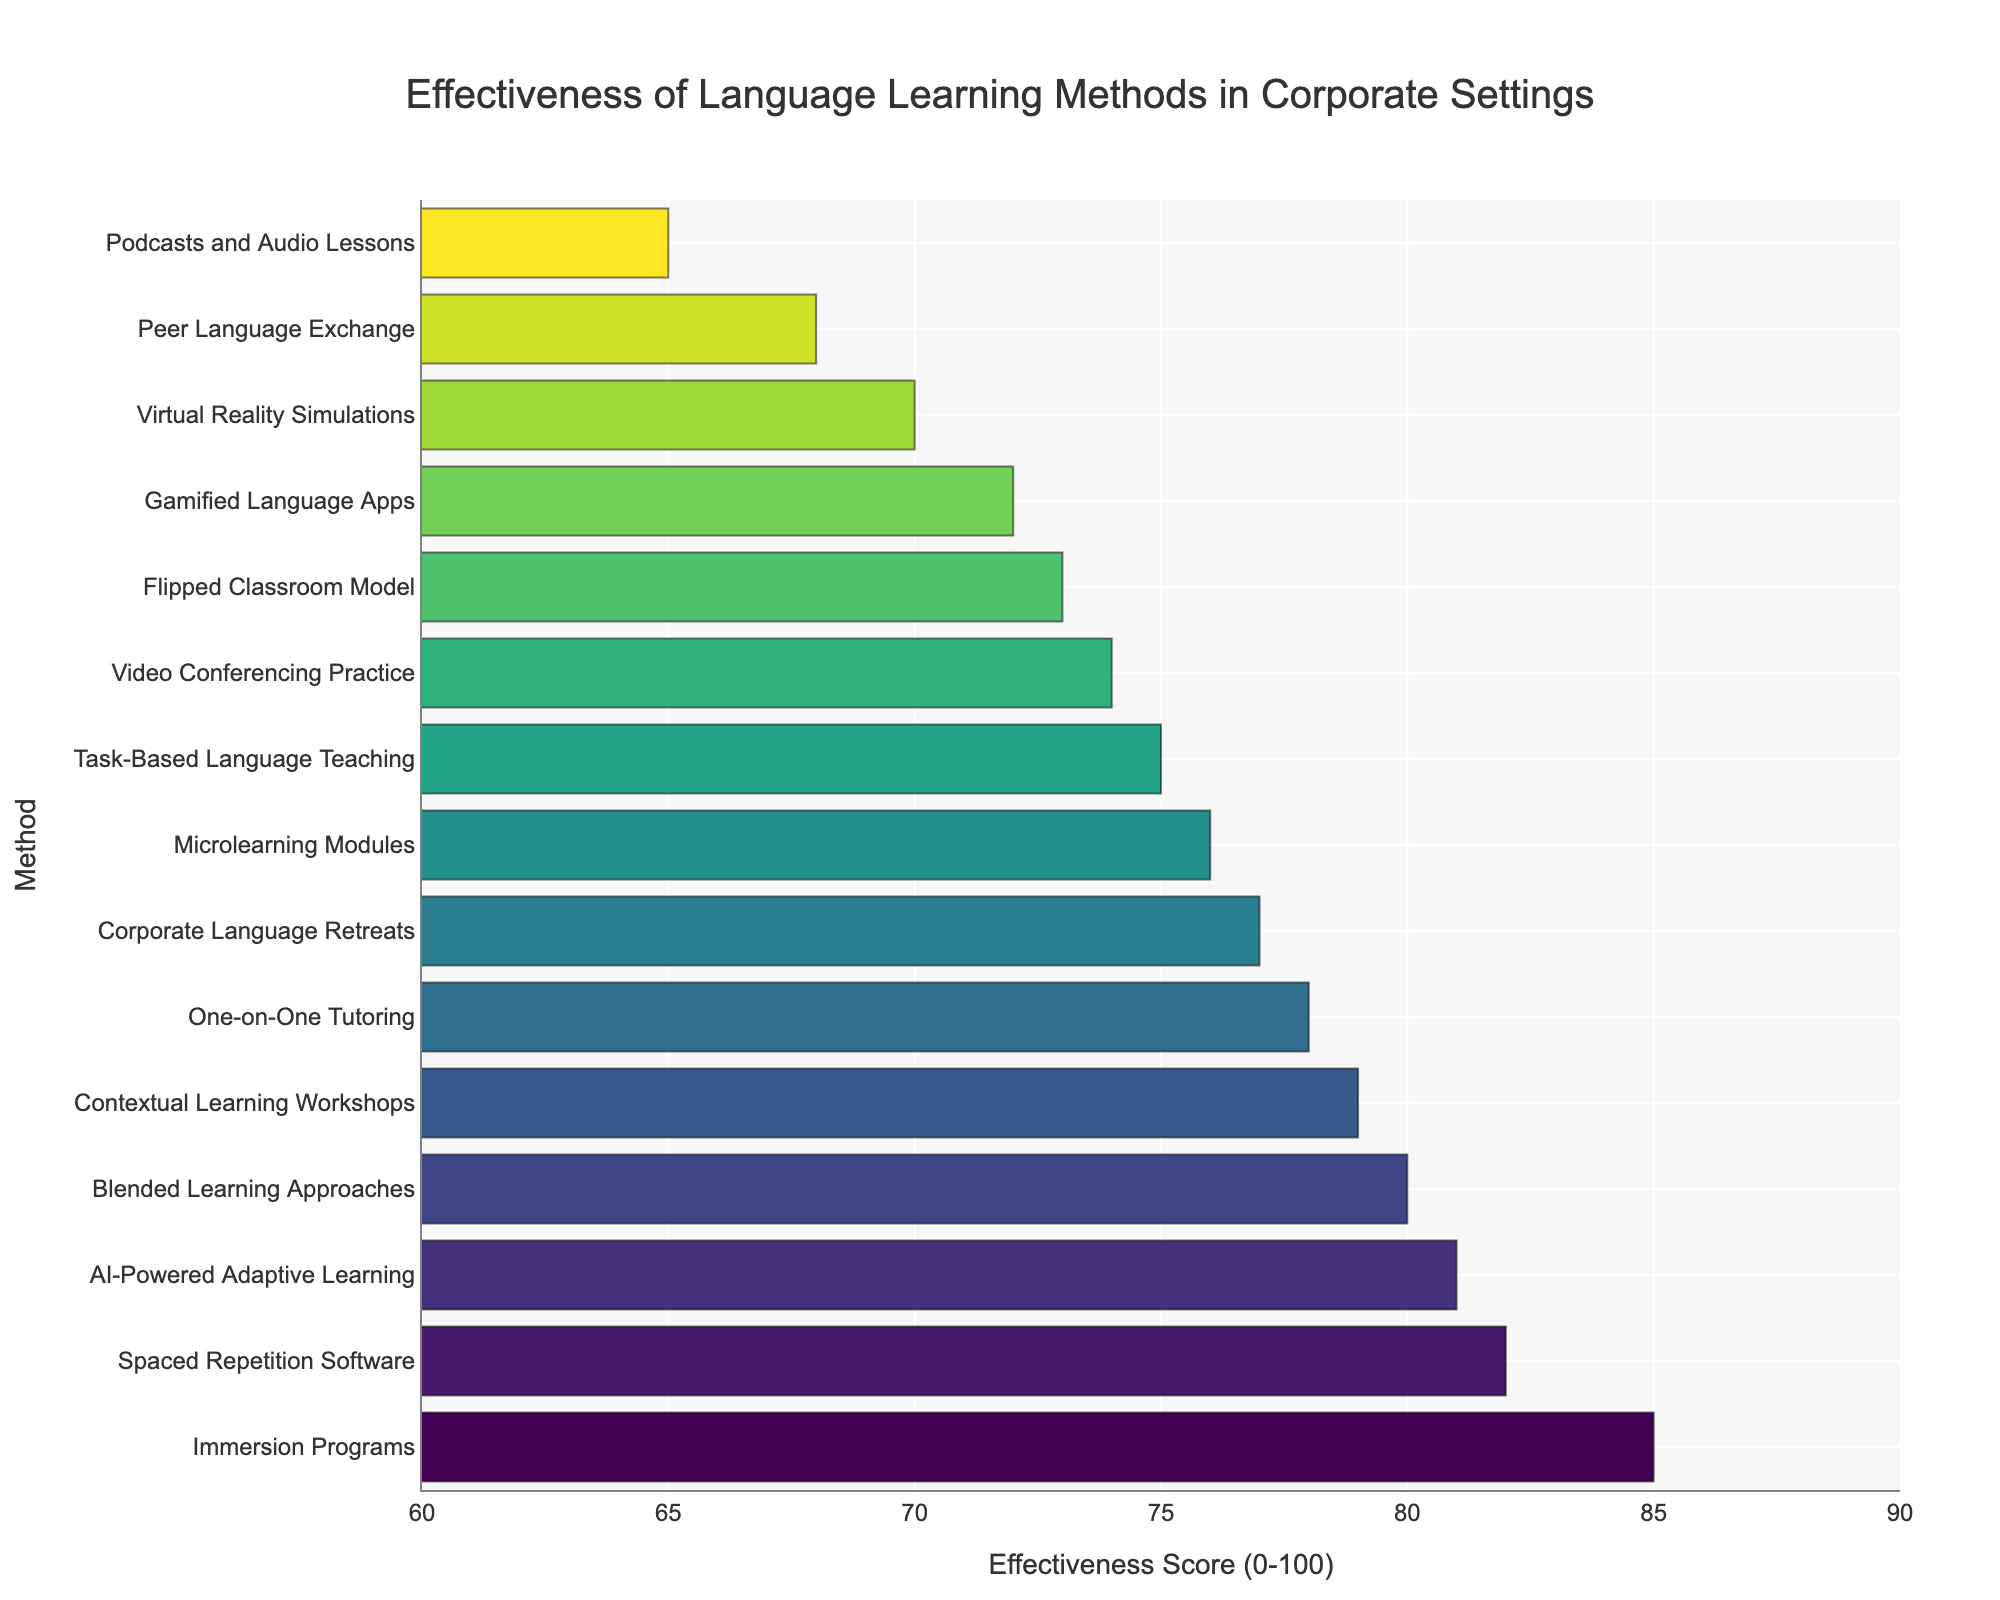Which language learning method is rated the highest in effectiveness? The highest rating corresponds to the method with the longest bar in the plot. The longest bar belongs to Immersion Programs.
Answer: Immersion Programs How many methods have an effectiveness score of 80 or above? The bars with scores ≥ 80 can be counted: Immersion Programs, Blended Learning Approaches, Spaced Repetition Software, AI-Powered Adaptive Learning, Contextual Learning Workshops.
Answer: 5 What is the difference in effectiveness score between Immersion Programs and Podcasts and Audio Lessons? The effectiveness score of Immersion Programs is 85, and Podcasts and Audio Lessons is 65. Subtract the smaller from the larger: 85 - 65.
Answer: 20 Which methods have effectiveness scores lower than 70? The bars with scores < 70 can be identified: Peer Language Exchange and Podcasts and Audio Lessons.
Answer: Peer Language Exchange, Podcasts and Audio Lessons List the methods with effectiveness scores between 70 and 75, inclusive. Identify the bars within the score range: Gamified Language Apps, Virtual Reality Simulations, Flipped Classroom Model, Task-Based Language Teaching, and Video Conferencing Practice.
Answer: Gamified Language Apps, Virtual Reality Simulations, Flipped Classroom Model, Task-Based Language Teaching, Video Conferencing Practice What is the average effectiveness score of One-on-One Tutoring, Microlearning Modules, and Virtual Reality Simulations? Add the scores (78 + 76 + 70) and divide by the number of methods: (78 + 76 + 70) / 3 = 224 / 3.
Answer: 74.67 What is the visual characteristic of the bar representing Spaced Repetition Software? The bar should be in the top section as it is one of the highest scores and has a specific color tone from the Viridis color scale applied.
Answer: High position, green tone Which method ranks just below AI-Powered Adaptive Learning in effectiveness? AI-Powered Adaptive Learning has the second-highest score (81). The next highest score is 80, corresponding to Blended Learning Approaches.
Answer: Blended Learning Approaches 